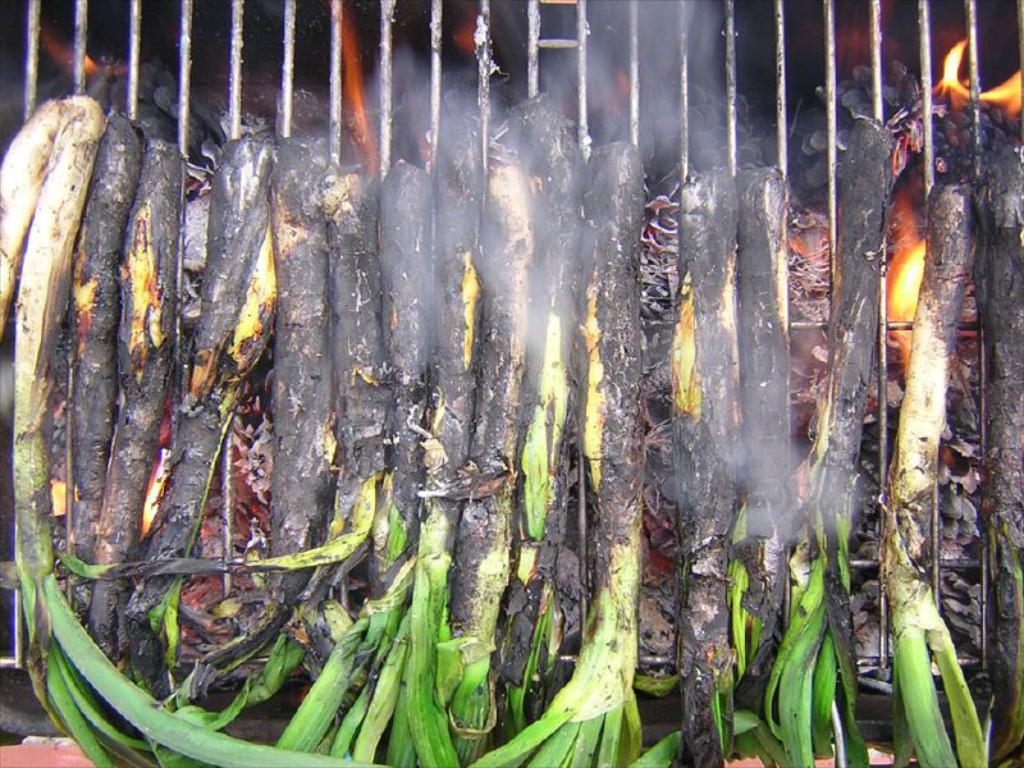What type of food is being prepared in the image? There are leafy vegetables on grills in the image. Can you describe the source of heat in the image? Yes, there is fire visible in the image. What scientific experiment is being conducted in the image? There is no scientific experiment visible in the image; it shows leafy vegetables being grilled over a fire. 